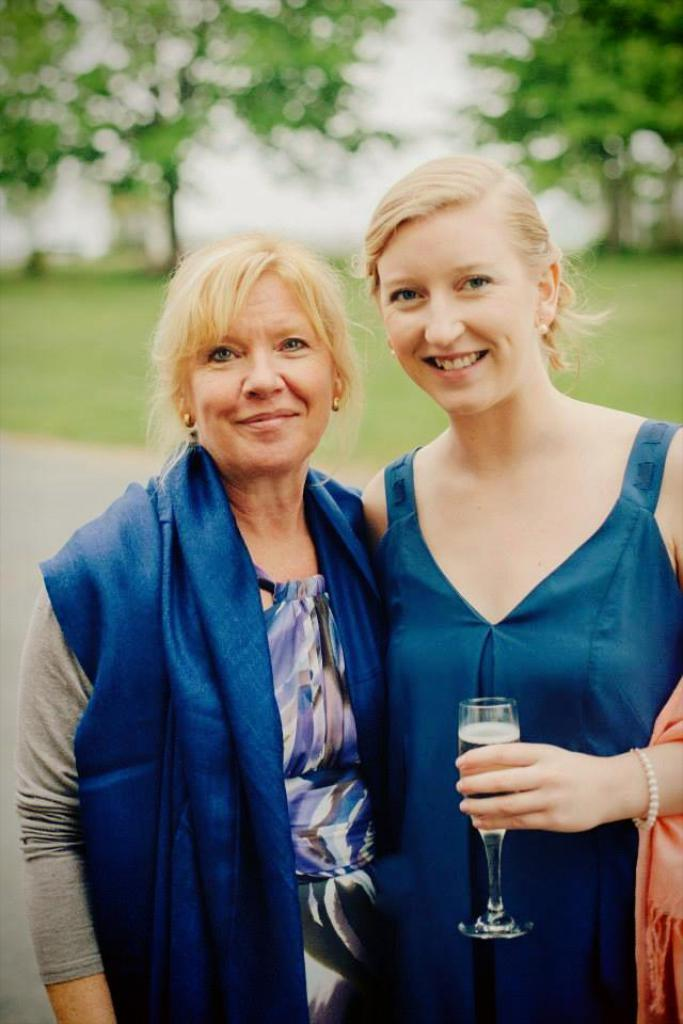How many women are present in the image? There are two women standing in the image. What is one of the women holding in her hand? One of the women is holding a wine glass in her hand. What can be seen in the background of the image? There are trees visible in the background of the image. What type of selection is being made by the woman holding the wine glass? There is no indication in the image that the woman is making any selection, as she is simply holding a wine glass. 